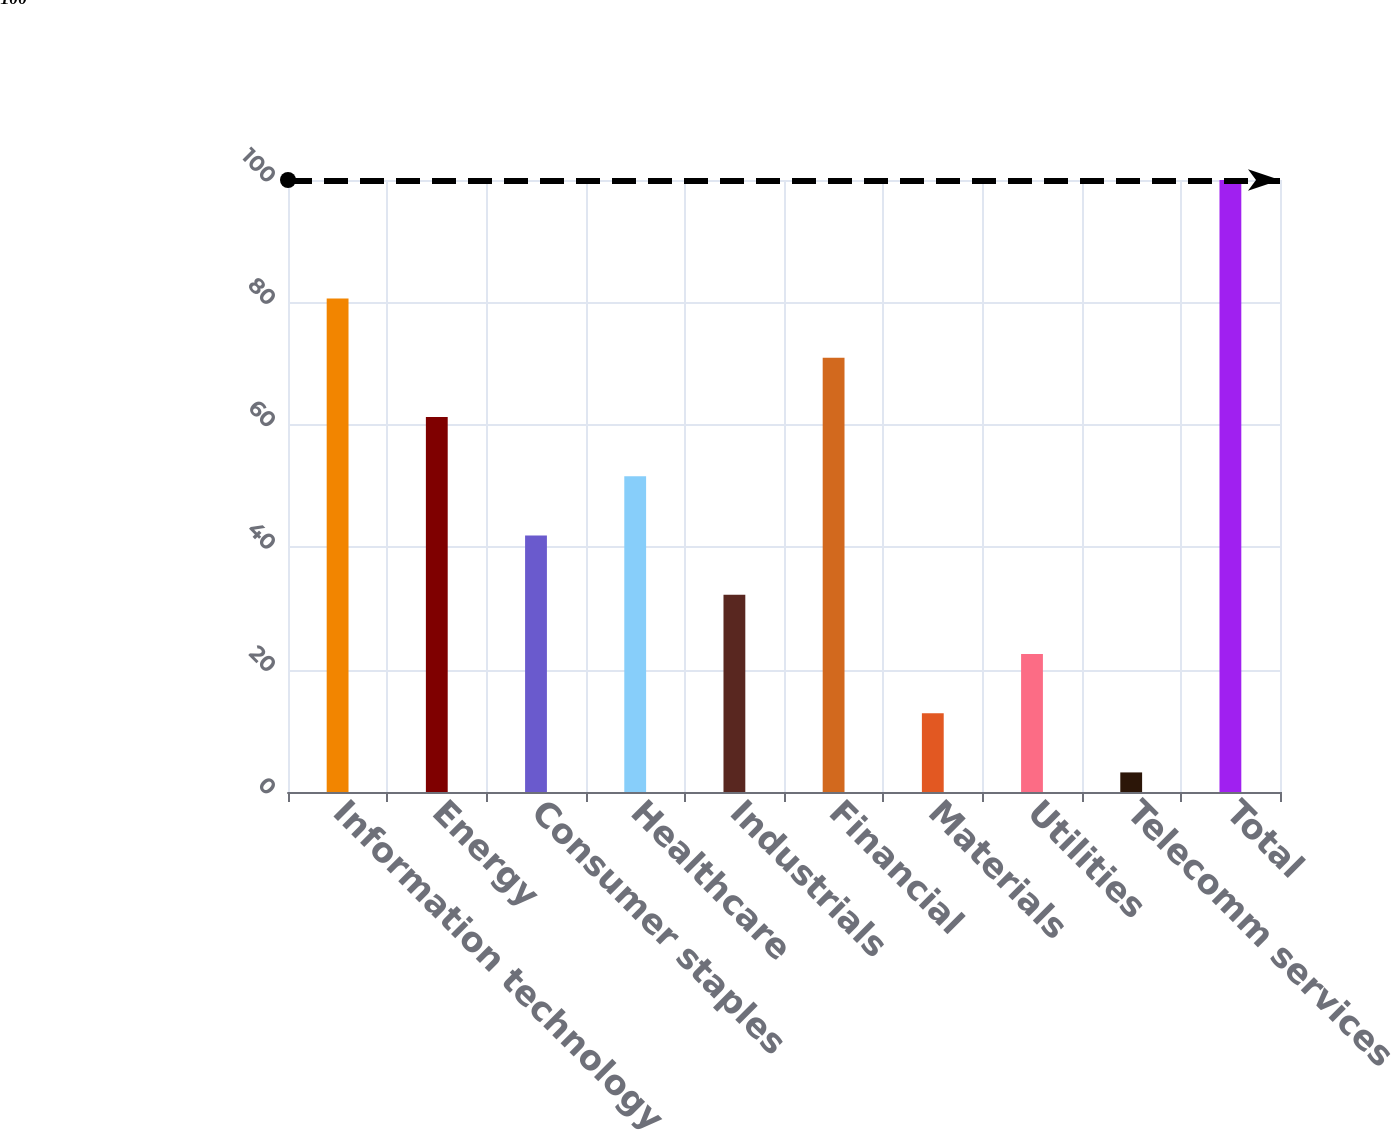Convert chart. <chart><loc_0><loc_0><loc_500><loc_500><bar_chart><fcel>Information technology<fcel>Energy<fcel>Consumer staples<fcel>Healthcare<fcel>Industrials<fcel>Financial<fcel>Materials<fcel>Utilities<fcel>Telecomm services<fcel>Total<nl><fcel>80.64<fcel>61.28<fcel>41.92<fcel>51.6<fcel>32.24<fcel>70.96<fcel>12.88<fcel>22.56<fcel>3.2<fcel>100<nl></chart> 